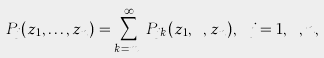Convert formula to latex. <formula><loc_0><loc_0><loc_500><loc_500>P _ { j } ( z _ { 1 } , \dots , z _ { n } ) = \sum _ { k = m _ { j } } ^ { \infty } P _ { j k } ( z _ { 1 } , \cdots , z _ { n } ) , \ j = 1 , \cdots , n ,</formula> 